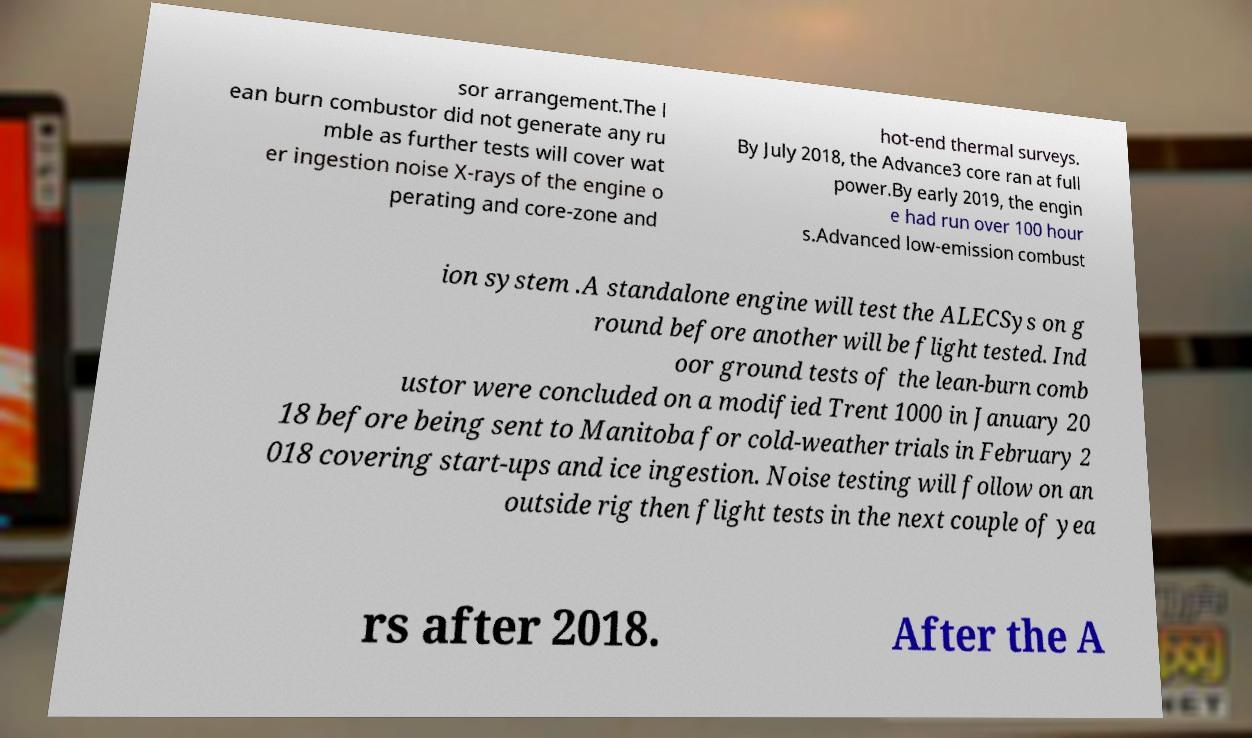Please identify and transcribe the text found in this image. sor arrangement.The l ean burn combustor did not generate any ru mble as further tests will cover wat er ingestion noise X-rays of the engine o perating and core-zone and hot-end thermal surveys. By July 2018, the Advance3 core ran at full power.By early 2019, the engin e had run over 100 hour s.Advanced low-emission combust ion system .A standalone engine will test the ALECSys on g round before another will be flight tested. Ind oor ground tests of the lean-burn comb ustor were concluded on a modified Trent 1000 in January 20 18 before being sent to Manitoba for cold-weather trials in February 2 018 covering start-ups and ice ingestion. Noise testing will follow on an outside rig then flight tests in the next couple of yea rs after 2018. After the A 